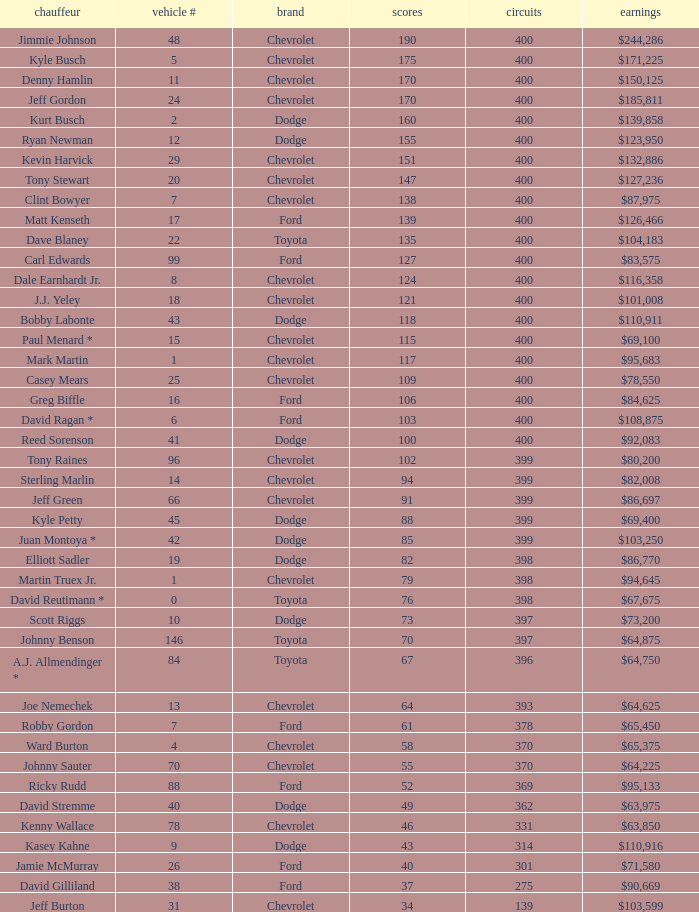Write the full table. {'header': ['chauffeur', 'vehicle #', 'brand', 'scores', 'circuits', 'earnings'], 'rows': [['Jimmie Johnson', '48', 'Chevrolet', '190', '400', '$244,286'], ['Kyle Busch', '5', 'Chevrolet', '175', '400', '$171,225'], ['Denny Hamlin', '11', 'Chevrolet', '170', '400', '$150,125'], ['Jeff Gordon', '24', 'Chevrolet', '170', '400', '$185,811'], ['Kurt Busch', '2', 'Dodge', '160', '400', '$139,858'], ['Ryan Newman', '12', 'Dodge', '155', '400', '$123,950'], ['Kevin Harvick', '29', 'Chevrolet', '151', '400', '$132,886'], ['Tony Stewart', '20', 'Chevrolet', '147', '400', '$127,236'], ['Clint Bowyer', '7', 'Chevrolet', '138', '400', '$87,975'], ['Matt Kenseth', '17', 'Ford', '139', '400', '$126,466'], ['Dave Blaney', '22', 'Toyota', '135', '400', '$104,183'], ['Carl Edwards', '99', 'Ford', '127', '400', '$83,575'], ['Dale Earnhardt Jr.', '8', 'Chevrolet', '124', '400', '$116,358'], ['J.J. Yeley', '18', 'Chevrolet', '121', '400', '$101,008'], ['Bobby Labonte', '43', 'Dodge', '118', '400', '$110,911'], ['Paul Menard *', '15', 'Chevrolet', '115', '400', '$69,100'], ['Mark Martin', '1', 'Chevrolet', '117', '400', '$95,683'], ['Casey Mears', '25', 'Chevrolet', '109', '400', '$78,550'], ['Greg Biffle', '16', 'Ford', '106', '400', '$84,625'], ['David Ragan *', '6', 'Ford', '103', '400', '$108,875'], ['Reed Sorenson', '41', 'Dodge', '100', '400', '$92,083'], ['Tony Raines', '96', 'Chevrolet', '102', '399', '$80,200'], ['Sterling Marlin', '14', 'Chevrolet', '94', '399', '$82,008'], ['Jeff Green', '66', 'Chevrolet', '91', '399', '$86,697'], ['Kyle Petty', '45', 'Dodge', '88', '399', '$69,400'], ['Juan Montoya *', '42', 'Dodge', '85', '399', '$103,250'], ['Elliott Sadler', '19', 'Dodge', '82', '398', '$86,770'], ['Martin Truex Jr.', '1', 'Chevrolet', '79', '398', '$94,645'], ['David Reutimann *', '0', 'Toyota', '76', '398', '$67,675'], ['Scott Riggs', '10', 'Dodge', '73', '397', '$73,200'], ['Johnny Benson', '146', 'Toyota', '70', '397', '$64,875'], ['A.J. Allmendinger *', '84', 'Toyota', '67', '396', '$64,750'], ['Joe Nemechek', '13', 'Chevrolet', '64', '393', '$64,625'], ['Robby Gordon', '7', 'Ford', '61', '378', '$65,450'], ['Ward Burton', '4', 'Chevrolet', '58', '370', '$65,375'], ['Johnny Sauter', '70', 'Chevrolet', '55', '370', '$64,225'], ['Ricky Rudd', '88', 'Ford', '52', '369', '$95,133'], ['David Stremme', '40', 'Dodge', '49', '362', '$63,975'], ['Kenny Wallace', '78', 'Chevrolet', '46', '331', '$63,850'], ['Kasey Kahne', '9', 'Dodge', '43', '314', '$110,916'], ['Jamie McMurray', '26', 'Ford', '40', '301', '$71,580'], ['David Gilliland', '38', 'Ford', '37', '275', '$90,669'], ['Jeff Burton', '31', 'Chevrolet', '34', '139', '$103,599']]} What were the winnings for the Chevrolet with a number larger than 29 and scored 102 points? $80,200. 